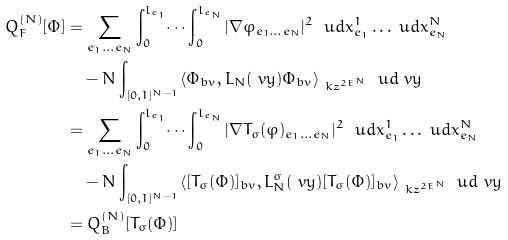Convert formula to latex. <formula><loc_0><loc_0><loc_500><loc_500>Q ^ { ( N ) } _ { F } [ \Phi ] & = \sum _ { e _ { 1 } \dots e _ { N } } \int _ { 0 } ^ { l _ { e _ { 1 } } } \dots \int _ { 0 } ^ { l _ { e _ { N } } } | \nabla \varphi _ { e _ { 1 } \dots e _ { N } } | ^ { 2 } \ \ u d x ^ { 1 } _ { e _ { 1 } } \dots \ u d x ^ { N } _ { e _ { N } } \\ & \quad - N \int _ { [ 0 , 1 ] ^ { N - 1 } } \langle \Phi _ { b v } , L _ { N } ( \ v y ) \Phi _ { b v } \rangle _ { \ k z ^ { 2 E ^ { N } } } \ \ u d \ v y \\ & = \sum _ { e _ { 1 } \dots e _ { N } } \int _ { 0 } ^ { l _ { e _ { 1 } } } \dots \int _ { 0 } ^ { l _ { e _ { N } } } | \nabla T _ { \sigma } ( \varphi ) _ { e _ { 1 } \dots e _ { N } } | ^ { 2 } \ \ u d x ^ { 1 } _ { e _ { 1 } } \dots \ u d x ^ { N } _ { e _ { N } } \\ & \quad - N \int _ { [ 0 , 1 ] ^ { N - 1 } } \langle [ T _ { \sigma } ( \Phi ) ] _ { b v } , L ^ { \sigma } _ { N } ( \ v y ) [ T _ { \sigma } ( \Phi ) ] _ { b v } \rangle _ { \ k z ^ { 2 E ^ { N } } } \ \ u d \ v y \\ & = Q ^ { ( N ) } _ { B } [ T _ { \sigma } ( \Phi ) ]</formula> 